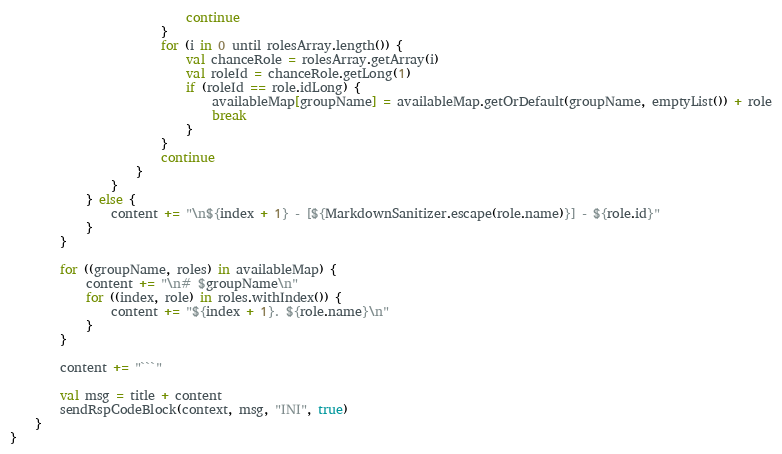Convert code to text. <code><loc_0><loc_0><loc_500><loc_500><_Kotlin_>                            continue
                        }
                        for (i in 0 until rolesArray.length()) {
                            val chanceRole = rolesArray.getArray(i)
                            val roleId = chanceRole.getLong(1)
                            if (roleId == role.idLong) {
                                availableMap[groupName] = availableMap.getOrDefault(groupName, emptyList()) + role
                                break
                            }
                        }
                        continue
                    }
                }
            } else {
                content += "\n${index + 1} - [${MarkdownSanitizer.escape(role.name)}] - ${role.id}"
            }
        }

        for ((groupName, roles) in availableMap) {
            content += "\n# $groupName\n"
            for ((index, role) in roles.withIndex()) {
                content += "${index + 1}. ${role.name}\n"
            }
        }

        content += "```"

        val msg = title + content
        sendRspCodeBlock(context, msg, "INI", true)
    }
}</code> 